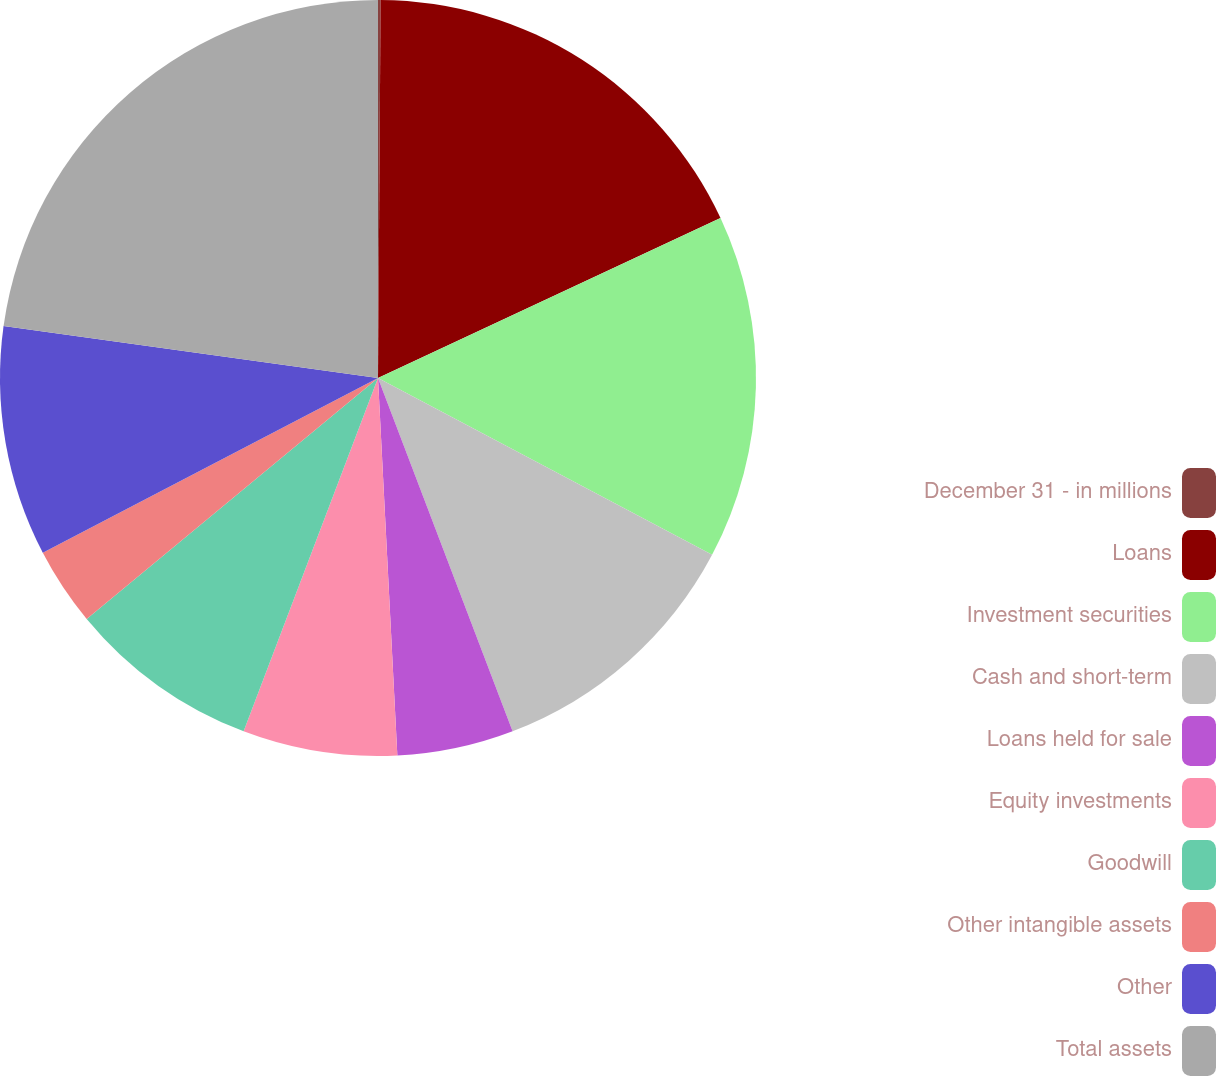<chart> <loc_0><loc_0><loc_500><loc_500><pie_chart><fcel>December 31 - in millions<fcel>Loans<fcel>Investment securities<fcel>Cash and short-term<fcel>Loans held for sale<fcel>Equity investments<fcel>Goodwill<fcel>Other intangible assets<fcel>Other<fcel>Total assets<nl><fcel>0.11%<fcel>17.94%<fcel>14.7%<fcel>11.46%<fcel>4.98%<fcel>6.6%<fcel>8.22%<fcel>3.35%<fcel>9.84%<fcel>22.81%<nl></chart> 